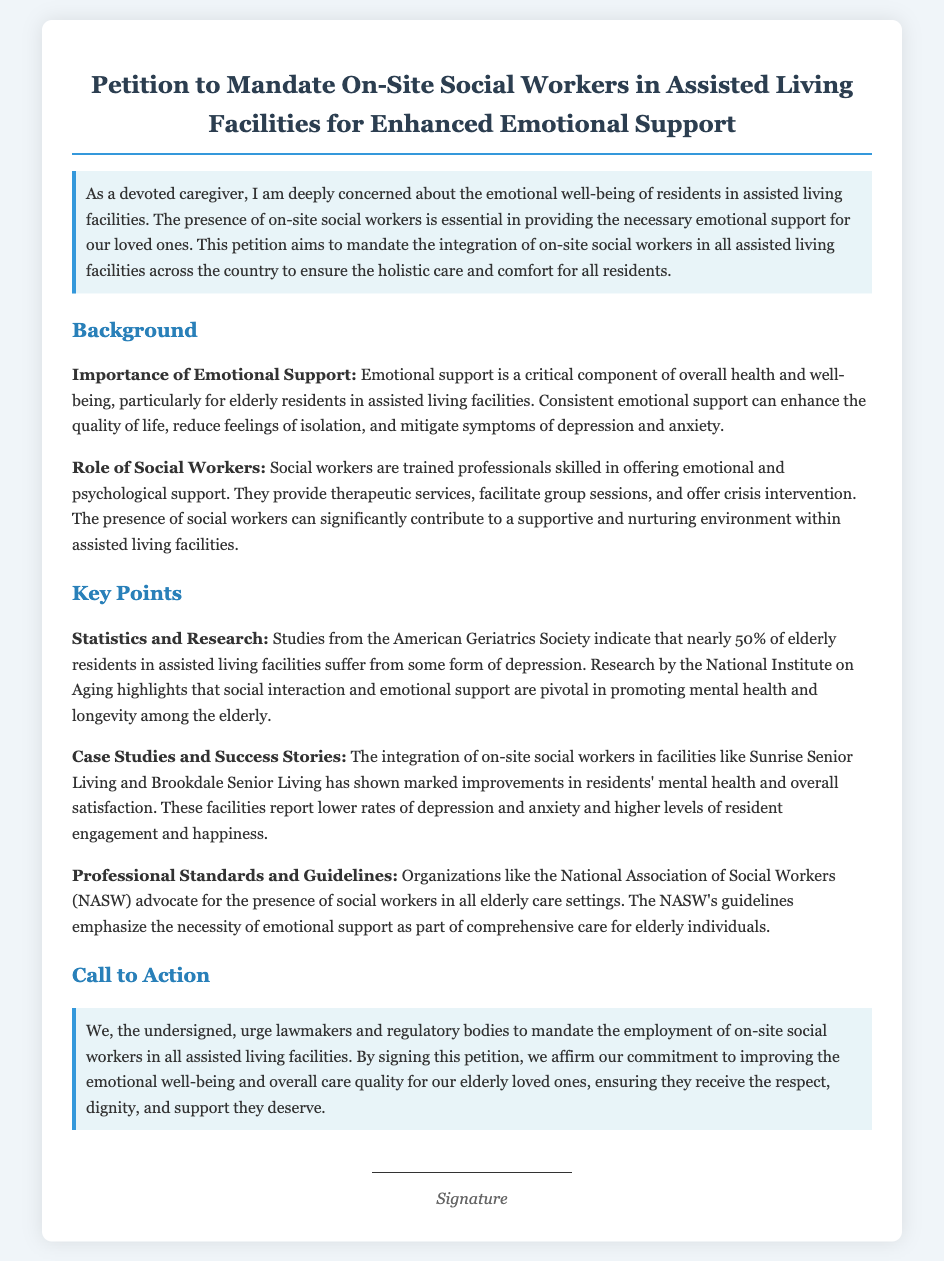What is the title of the petition? The title of the petition is clearly stated at the top of the document.
Answer: Petition to Mandate On-Site Social Workers in Assisted Living Facilities for Enhanced Emotional Support What organization highlights the necessity of emotional support? The document mentions an organization that advocates for the presence of social workers in elderly care settings.
Answer: National Association of Social Workers (NASW) What percentage of elderly residents in assisted living suffer from depression? The document provides a statistic from a reputable source regarding elderly residents' mental health.
Answer: nearly 50% Name one facility that has integrated on-site social workers. The document lists examples of facilities that have successfully integrated social workers.
Answer: Sunrise Senior Living What is the role of social workers in assisted living facilities? The document describes what social workers are trained to do in the context of emotional support.
Answer: Offering emotional and psychological support What is the main purpose of the petition? The petition has a specific goal related to the well-being of residents in assisted living facilities.
Answer: To mandate the employment of on-site social workers What type of petition is this document? The document specifies the nature of its content related to social workers and emotional support.
Answer: Signed Petition What does the petition aim to improve? The document states a clear intention regarding the well-being of individuals in assisted living.
Answer: Emotional well-being 